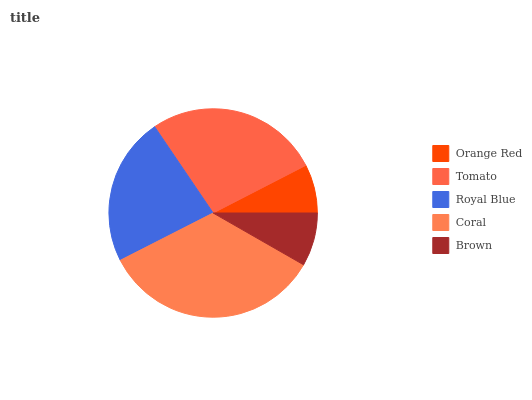Is Orange Red the minimum?
Answer yes or no. Yes. Is Coral the maximum?
Answer yes or no. Yes. Is Tomato the minimum?
Answer yes or no. No. Is Tomato the maximum?
Answer yes or no. No. Is Tomato greater than Orange Red?
Answer yes or no. Yes. Is Orange Red less than Tomato?
Answer yes or no. Yes. Is Orange Red greater than Tomato?
Answer yes or no. No. Is Tomato less than Orange Red?
Answer yes or no. No. Is Royal Blue the high median?
Answer yes or no. Yes. Is Royal Blue the low median?
Answer yes or no. Yes. Is Coral the high median?
Answer yes or no. No. Is Tomato the low median?
Answer yes or no. No. 